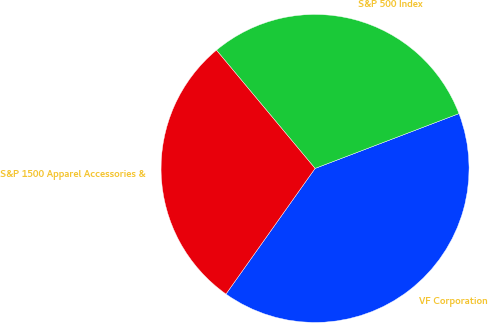Convert chart. <chart><loc_0><loc_0><loc_500><loc_500><pie_chart><fcel>VF Corporation<fcel>S&P 500 Index<fcel>S&P 1500 Apparel Accessories &<nl><fcel>40.61%<fcel>30.27%<fcel>29.12%<nl></chart> 